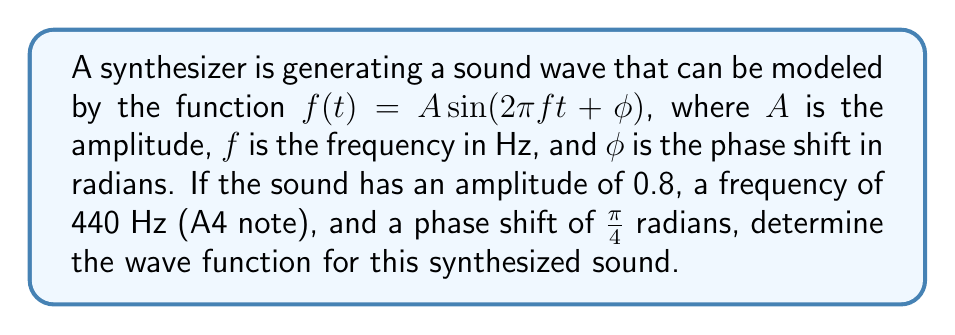Provide a solution to this math problem. To determine the wave function, we need to substitute the given values into the general form of the sine wave function:

$f(t) = A \sin(2\pi ft + \phi)$

Given:
- Amplitude (A) = 0.8
- Frequency (f) = 440 Hz
- Phase shift ($\phi$) = $\frac{\pi}{4}$ radians

Step 1: Substitute the amplitude (A) = 0.8
$f(t) = 0.8 \sin(2\pi ft + \phi)$

Step 2: Substitute the frequency (f) = 440 Hz
$f(t) = 0.8 \sin(2\pi(440)t + \phi)$

Step 3: Simplify the coefficient of t
$f(t) = 0.8 \sin(880\pi t + \phi)$

Step 4: Substitute the phase shift ($\phi$) = $\frac{\pi}{4}$
$f(t) = 0.8 \sin(880\pi t + \frac{\pi}{4})$

This is the final wave function for the synthesized sound.
Answer: $f(t) = 0.8 \sin(880\pi t + \frac{\pi}{4})$ 